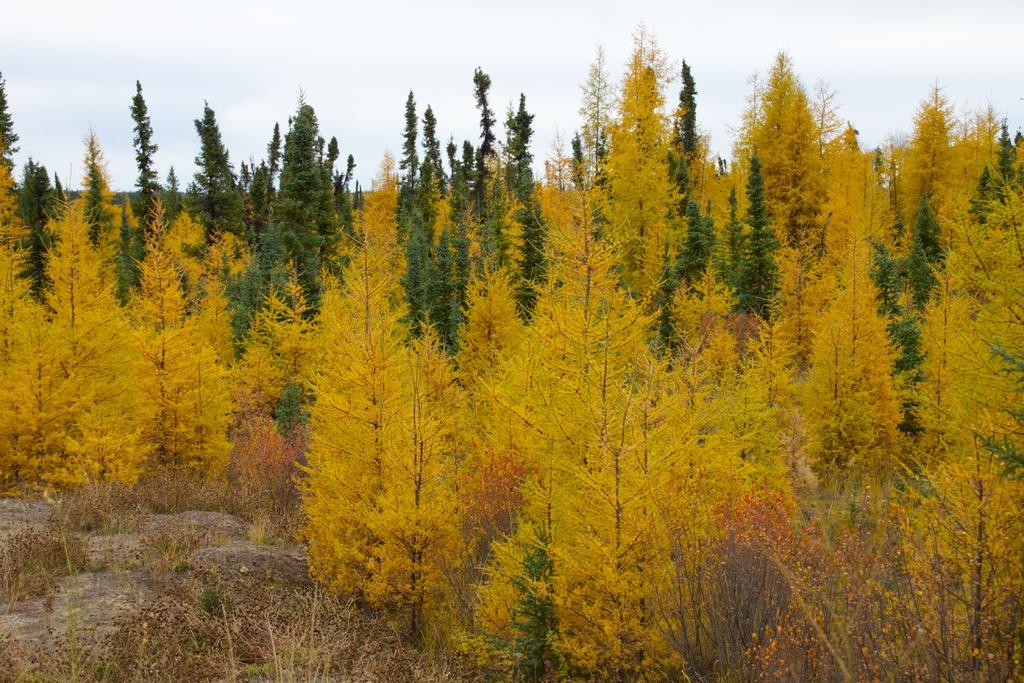What is visible in the background of the image? The sky is visible in the image. What can be seen in the sky? Clouds are present in the sky. What type of vegetation is visible in the image? There are trees in the image. What is visible at the bottom of the image? The ground is visible in the image. What type of wool is being used to make the bed in the image? There is no bed or wool present in the image; it only features the sky, clouds, trees, and ground. 